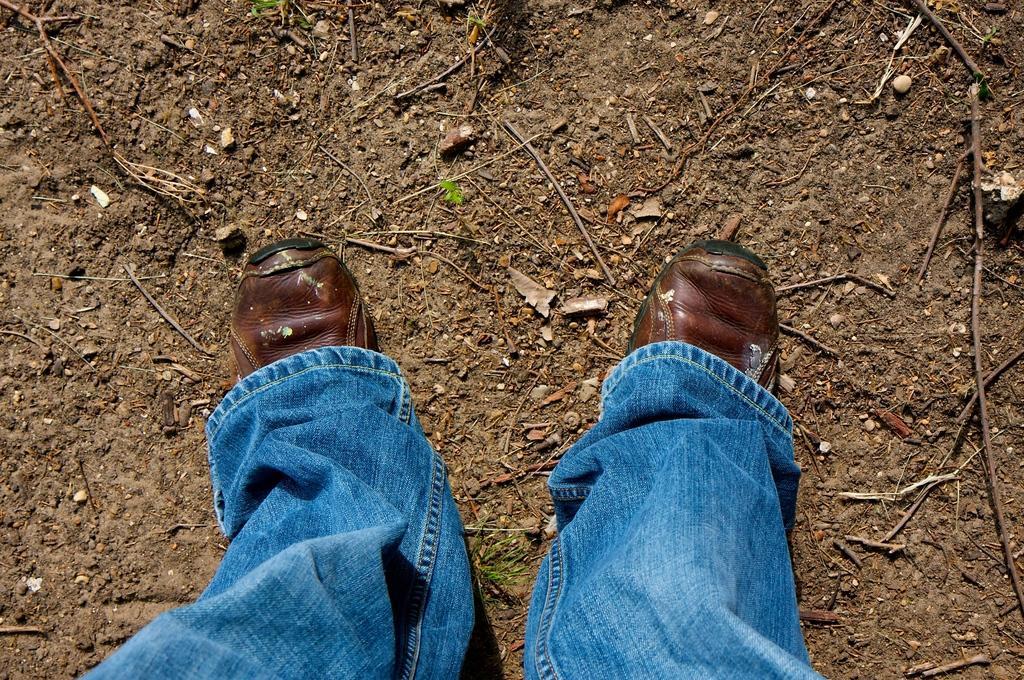How would you summarize this image in a sentence or two? In this image I can see a person's legs wearing a jeans and shoes. It seems like this person is standing. Here I can see many sticks on the ground. 